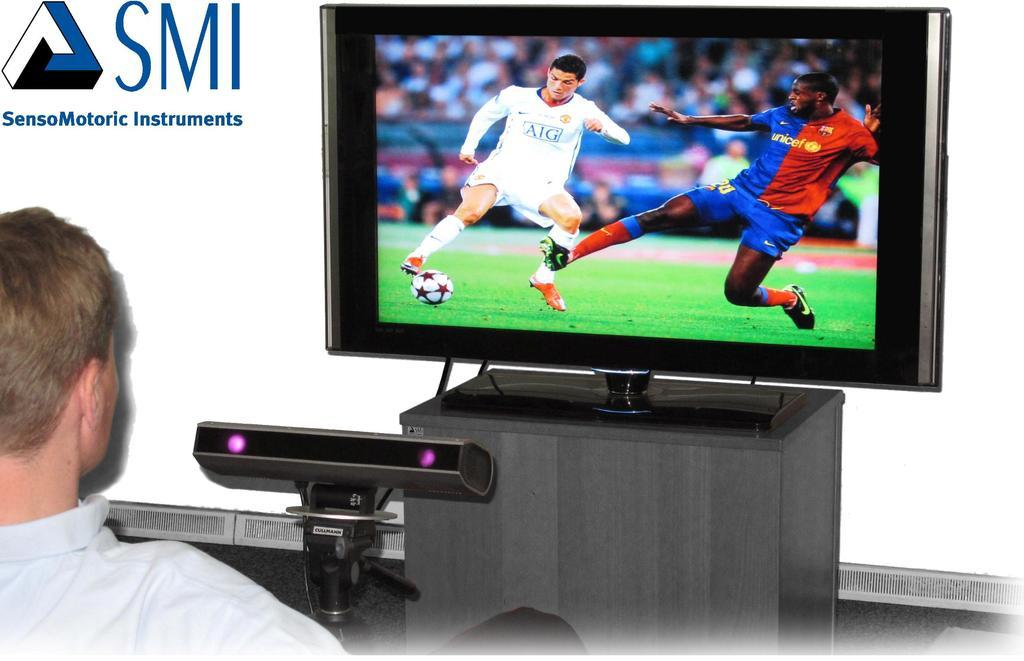<image>
Give a short and clear explanation of the subsequent image. the letters SMI next to a tv screen 